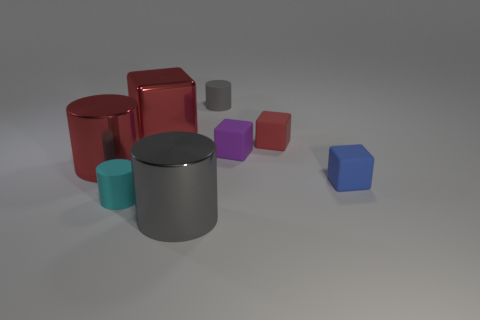Is there a large metallic cylinder that is in front of the gray object that is in front of the gray cylinder behind the purple cube?
Offer a very short reply. No. Is there any other thing that has the same shape as the red matte thing?
Offer a very short reply. Yes. There is a rubber cylinder that is in front of the tiny gray cylinder; is it the same color as the block that is on the left side of the small gray matte cylinder?
Provide a short and direct response. No. Are any tiny cubes visible?
Make the answer very short. Yes. There is another small cube that is the same color as the shiny cube; what is its material?
Give a very brief answer. Rubber. There is a gray object in front of the tiny matte object left of the large thing that is behind the small purple thing; what size is it?
Make the answer very short. Large. Does the small purple matte thing have the same shape as the small thing left of the gray shiny cylinder?
Provide a succinct answer. No. Is there a big metallic sphere that has the same color as the large block?
Offer a terse response. No. How many balls are large yellow matte objects or big objects?
Your answer should be very brief. 0. Is there another matte thing that has the same shape as the large gray object?
Make the answer very short. Yes. 